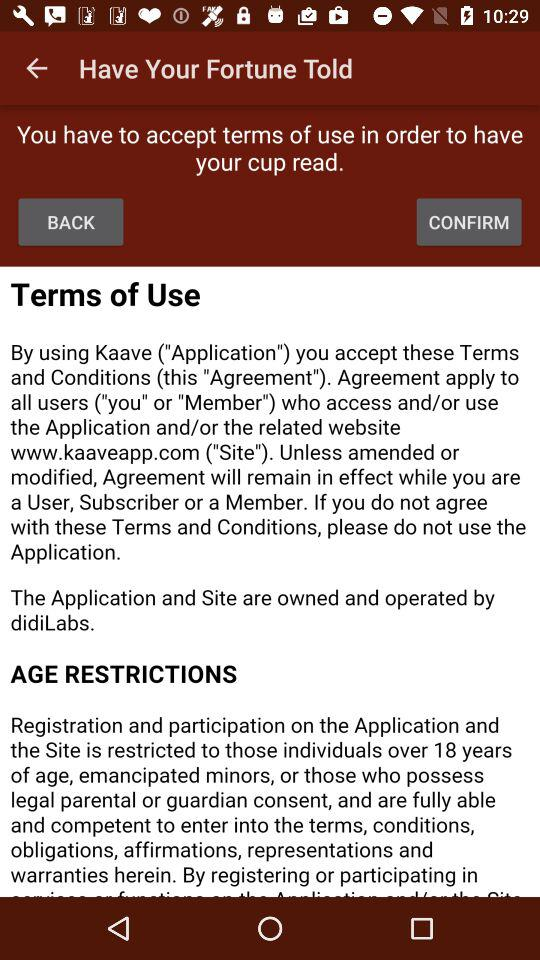What is the name of the application? The name of the application is "Kaave". 